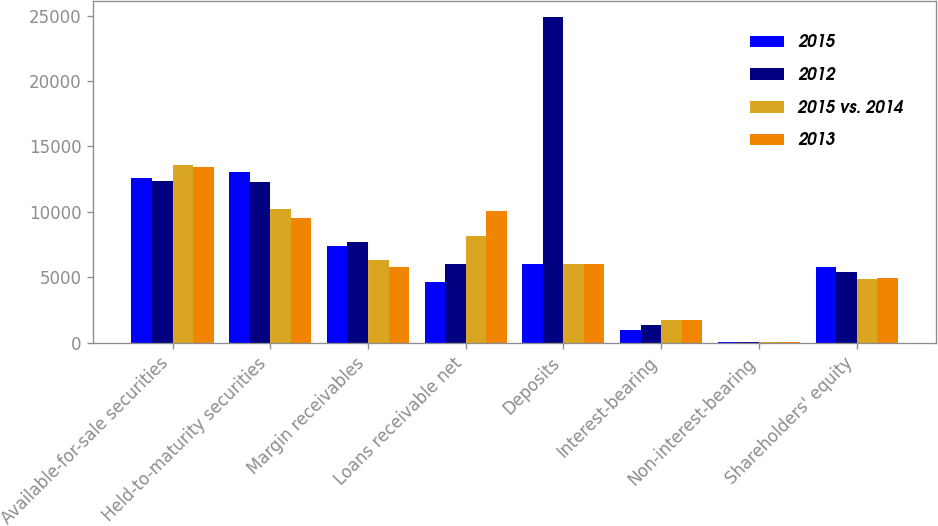Convert chart to OTSL. <chart><loc_0><loc_0><loc_500><loc_500><stacked_bar_chart><ecel><fcel>Available-for-sale securities<fcel>Held-to-maturity securities<fcel>Margin receivables<fcel>Loans receivable net<fcel>Deposits<fcel>Interest-bearing<fcel>Non-interest-bearing<fcel>Shareholders' equity<nl><fcel>2015<fcel>12589<fcel>13013<fcel>7398<fcel>4613<fcel>5979<fcel>989<fcel>8<fcel>5799<nl><fcel>2012<fcel>12388<fcel>12248<fcel>7675<fcel>5979<fcel>24890<fcel>1328<fcel>38<fcel>5375<nl><fcel>2015 vs. 2014<fcel>13592<fcel>10181<fcel>6353<fcel>8123<fcel>5979<fcel>1726<fcel>42<fcel>4856<nl><fcel>2013<fcel>13443<fcel>9540<fcel>5804<fcel>10099<fcel>5979<fcel>1722<fcel>43<fcel>4904<nl></chart> 